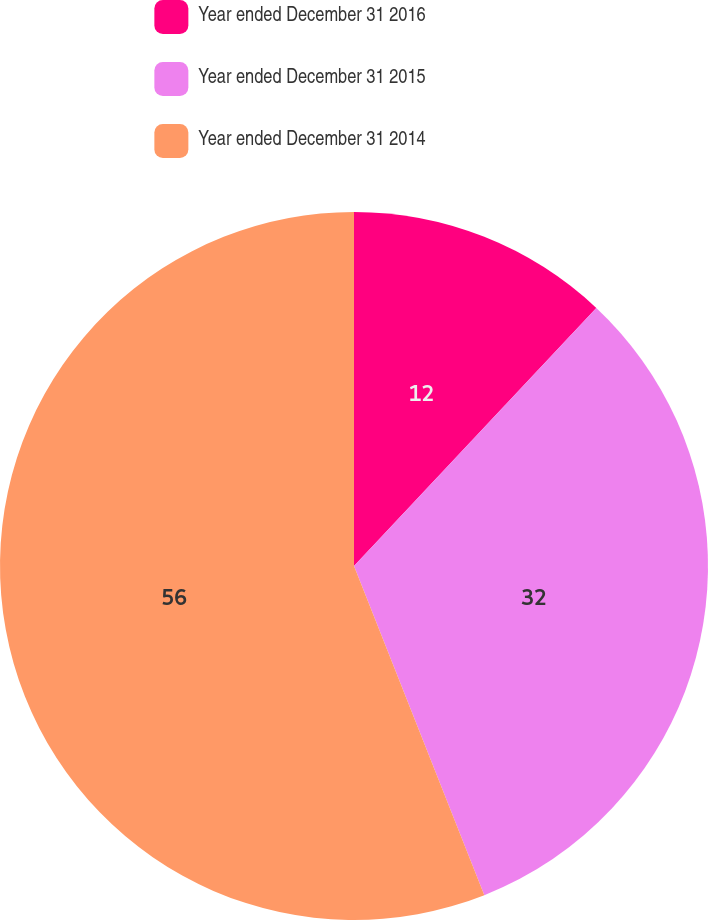<chart> <loc_0><loc_0><loc_500><loc_500><pie_chart><fcel>Year ended December 31 2016<fcel>Year ended December 31 2015<fcel>Year ended December 31 2014<nl><fcel>12.0%<fcel>32.0%<fcel>56.0%<nl></chart> 